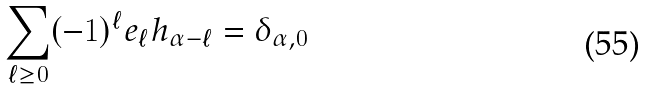Convert formula to latex. <formula><loc_0><loc_0><loc_500><loc_500>\sum _ { \ell \geq 0 } ( - 1 ) ^ { \ell } e _ { \ell } h _ { \alpha - \ell } = \delta _ { \alpha , 0 }</formula> 